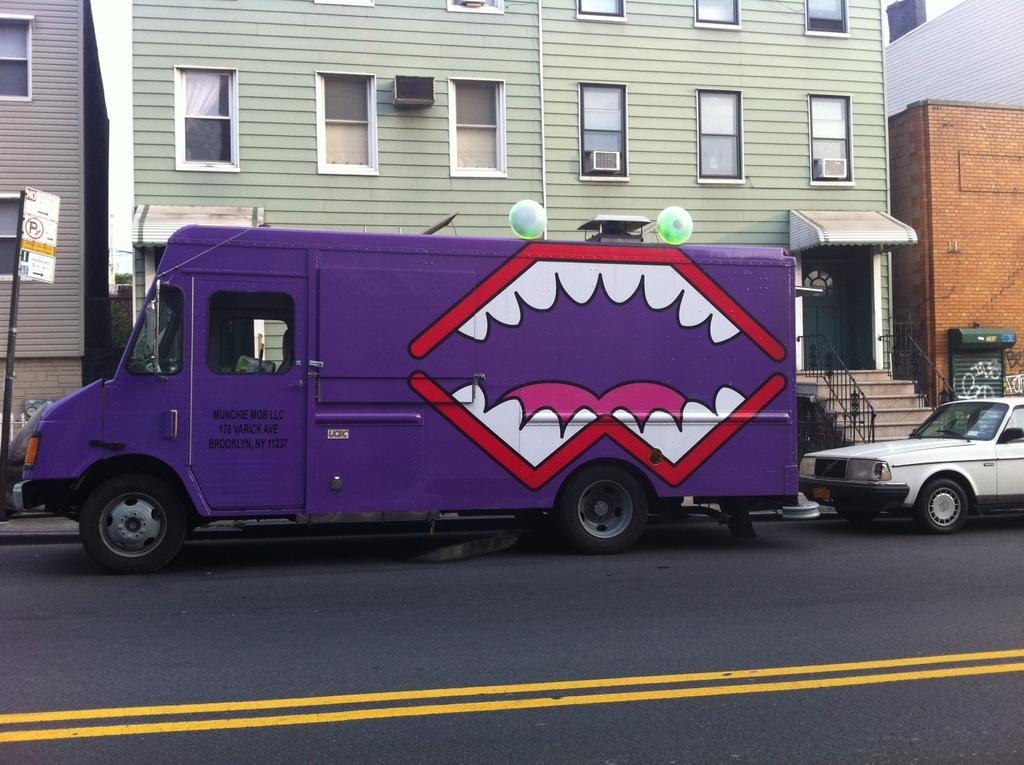What color is the truck in the image? The truck in the image is purple. What color is the car in the image? The car in the image is white. What can be seen in the image that people use to move between different levels? There are stairs in the image. What type of structures can be seen in the image? There are buildings in the image. What feature of the buildings is visible in the image? There are windows in the image. What is hanging in the image that might be used for advertising or conveying information? There is a banner in the image. What type of tooth is visible in the image? There are no teeth present in the image. What type of weather can be seen in the image? The image does not show any weather conditions; it is a still image. 